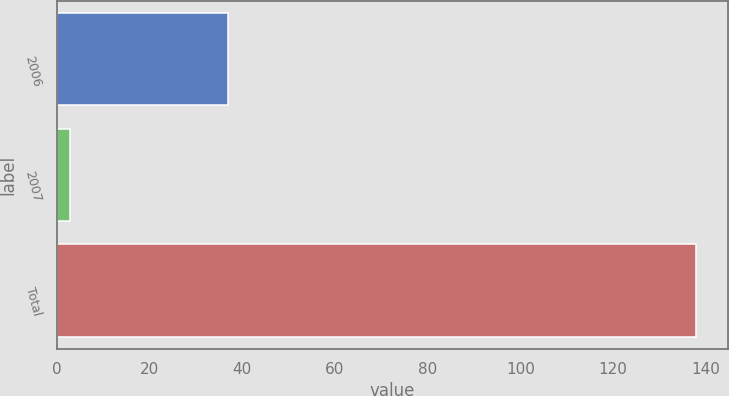Convert chart. <chart><loc_0><loc_0><loc_500><loc_500><bar_chart><fcel>2006<fcel>2007<fcel>Total<nl><fcel>37<fcel>3<fcel>138<nl></chart> 